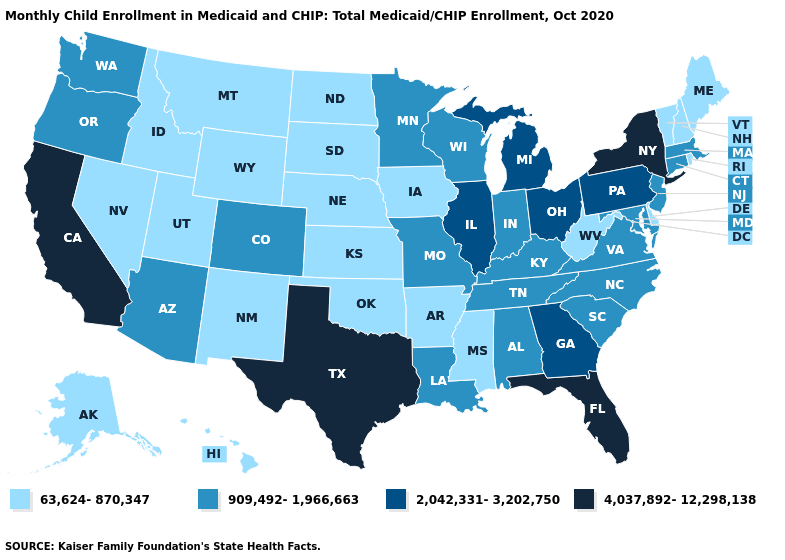Name the states that have a value in the range 63,624-870,347?
Quick response, please. Alaska, Arkansas, Delaware, Hawaii, Idaho, Iowa, Kansas, Maine, Mississippi, Montana, Nebraska, Nevada, New Hampshire, New Mexico, North Dakota, Oklahoma, Rhode Island, South Dakota, Utah, Vermont, West Virginia, Wyoming. What is the value of Arizona?
Short answer required. 909,492-1,966,663. Name the states that have a value in the range 2,042,331-3,202,750?
Quick response, please. Georgia, Illinois, Michigan, Ohio, Pennsylvania. Name the states that have a value in the range 4,037,892-12,298,138?
Write a very short answer. California, Florida, New York, Texas. Does Oregon have the highest value in the USA?
Concise answer only. No. What is the lowest value in states that border Tennessee?
Answer briefly. 63,624-870,347. Name the states that have a value in the range 909,492-1,966,663?
Write a very short answer. Alabama, Arizona, Colorado, Connecticut, Indiana, Kentucky, Louisiana, Maryland, Massachusetts, Minnesota, Missouri, New Jersey, North Carolina, Oregon, South Carolina, Tennessee, Virginia, Washington, Wisconsin. Name the states that have a value in the range 4,037,892-12,298,138?
Give a very brief answer. California, Florida, New York, Texas. Name the states that have a value in the range 909,492-1,966,663?
Keep it brief. Alabama, Arizona, Colorado, Connecticut, Indiana, Kentucky, Louisiana, Maryland, Massachusetts, Minnesota, Missouri, New Jersey, North Carolina, Oregon, South Carolina, Tennessee, Virginia, Washington, Wisconsin. What is the value of New York?
Give a very brief answer. 4,037,892-12,298,138. What is the lowest value in states that border Maine?
Answer briefly. 63,624-870,347. Name the states that have a value in the range 63,624-870,347?
Answer briefly. Alaska, Arkansas, Delaware, Hawaii, Idaho, Iowa, Kansas, Maine, Mississippi, Montana, Nebraska, Nevada, New Hampshire, New Mexico, North Dakota, Oklahoma, Rhode Island, South Dakota, Utah, Vermont, West Virginia, Wyoming. Does the map have missing data?
Give a very brief answer. No. What is the value of New Hampshire?
Write a very short answer. 63,624-870,347. What is the value of Ohio?
Short answer required. 2,042,331-3,202,750. 